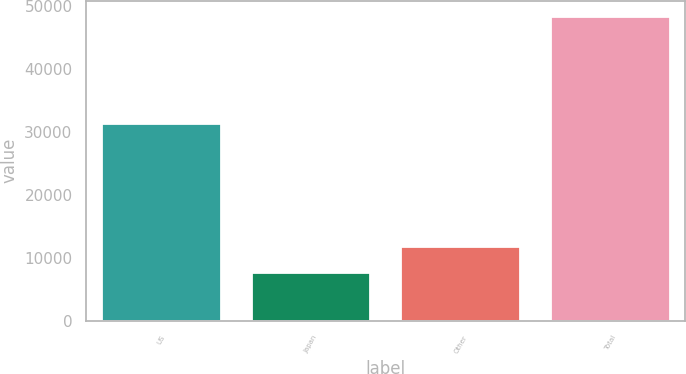<chart> <loc_0><loc_0><loc_500><loc_500><bar_chart><fcel>US<fcel>Japan<fcel>Other<fcel>Total<nl><fcel>31500<fcel>7833<fcel>11893.4<fcel>48437<nl></chart> 